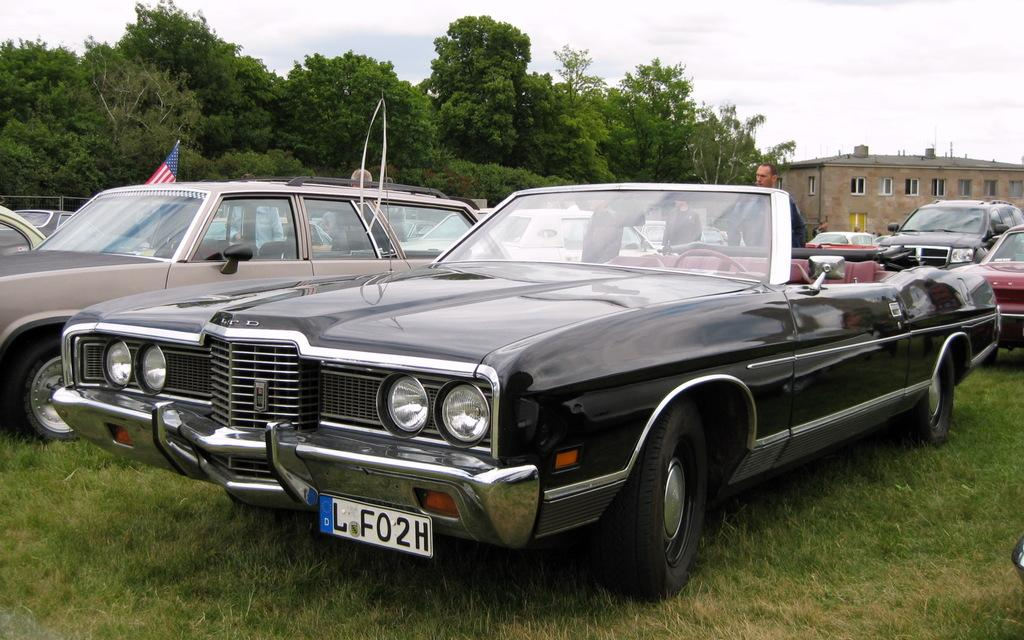What can be seen in the foreground of the image? In the foreground of the image, there are fleets of cars and a group of people on the grass. What is visible in the background of the image? In the background of the image, there are trees, buildings, and the sky. Can you describe the time of day when the image was taken? The image appears to be taken during the day, as the sky is visible and there is sufficient light. What type of creature is delivering a parcel in the image? There is no creature or parcel present in the image. What are the hopes and dreams of the people in the image? The image does not provide information about the hopes and dreams of the people; it only shows them on the grass. 